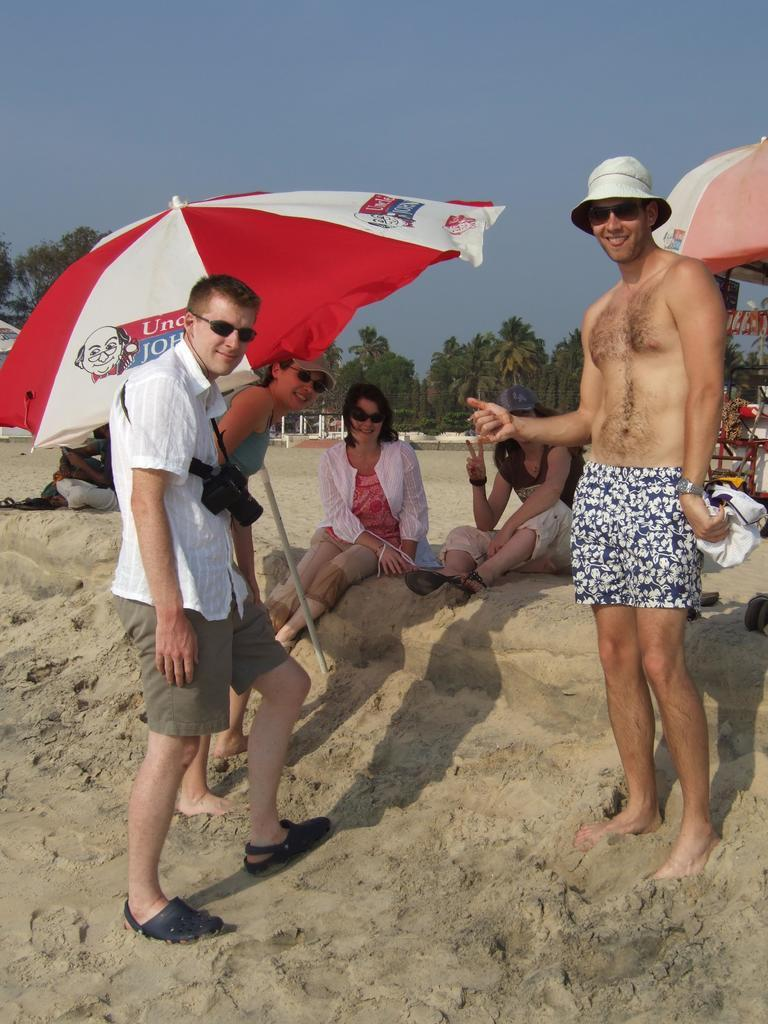How many people are in the image? There are two men and a woman standing and smiling, making a total of three people in the image. What can be seen in the background of the image? Trees are visible in the background of the image. What are the women sitting on in the image? The two women are sitting on the sand. What type of shelter is present in the image? Beach umbrellas are present in the image. What type of destruction can be seen in the image? There is no destruction present in the image; it features people standing and sitting near beach umbrellas and trees. What type of drug is visible in the image? There is no drug present in the image; it features people enjoying a day at the beach. 